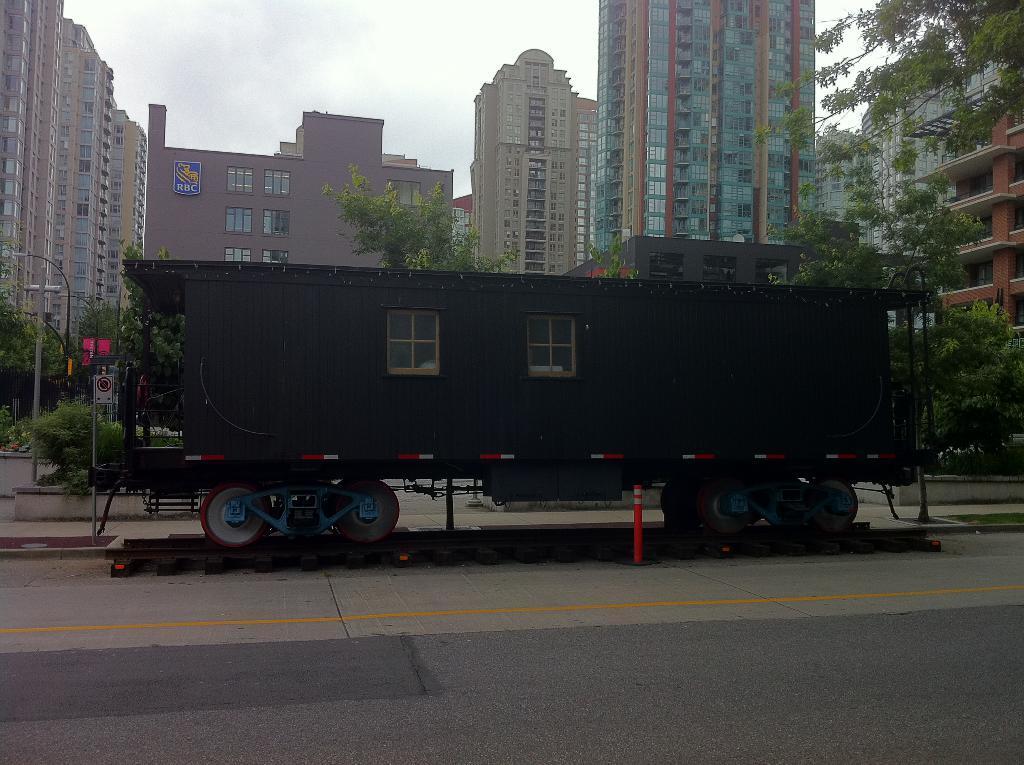Could you give a brief overview of what you see in this image? In this image I can see a train on the railway track. Back I can see few buildings, windows, trees, light poles, signboards. The sky is in white color. 